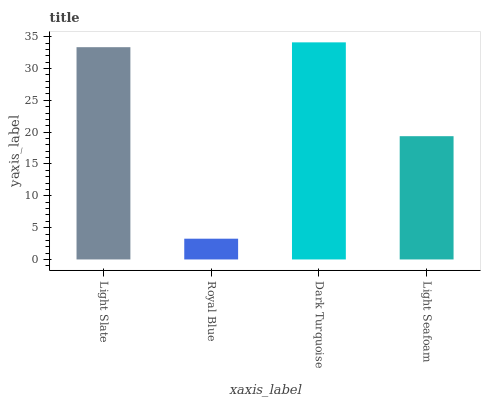Is Royal Blue the minimum?
Answer yes or no. Yes. Is Dark Turquoise the maximum?
Answer yes or no. Yes. Is Dark Turquoise the minimum?
Answer yes or no. No. Is Royal Blue the maximum?
Answer yes or no. No. Is Dark Turquoise greater than Royal Blue?
Answer yes or no. Yes. Is Royal Blue less than Dark Turquoise?
Answer yes or no. Yes. Is Royal Blue greater than Dark Turquoise?
Answer yes or no. No. Is Dark Turquoise less than Royal Blue?
Answer yes or no. No. Is Light Slate the high median?
Answer yes or no. Yes. Is Light Seafoam the low median?
Answer yes or no. Yes. Is Dark Turquoise the high median?
Answer yes or no. No. Is Dark Turquoise the low median?
Answer yes or no. No. 